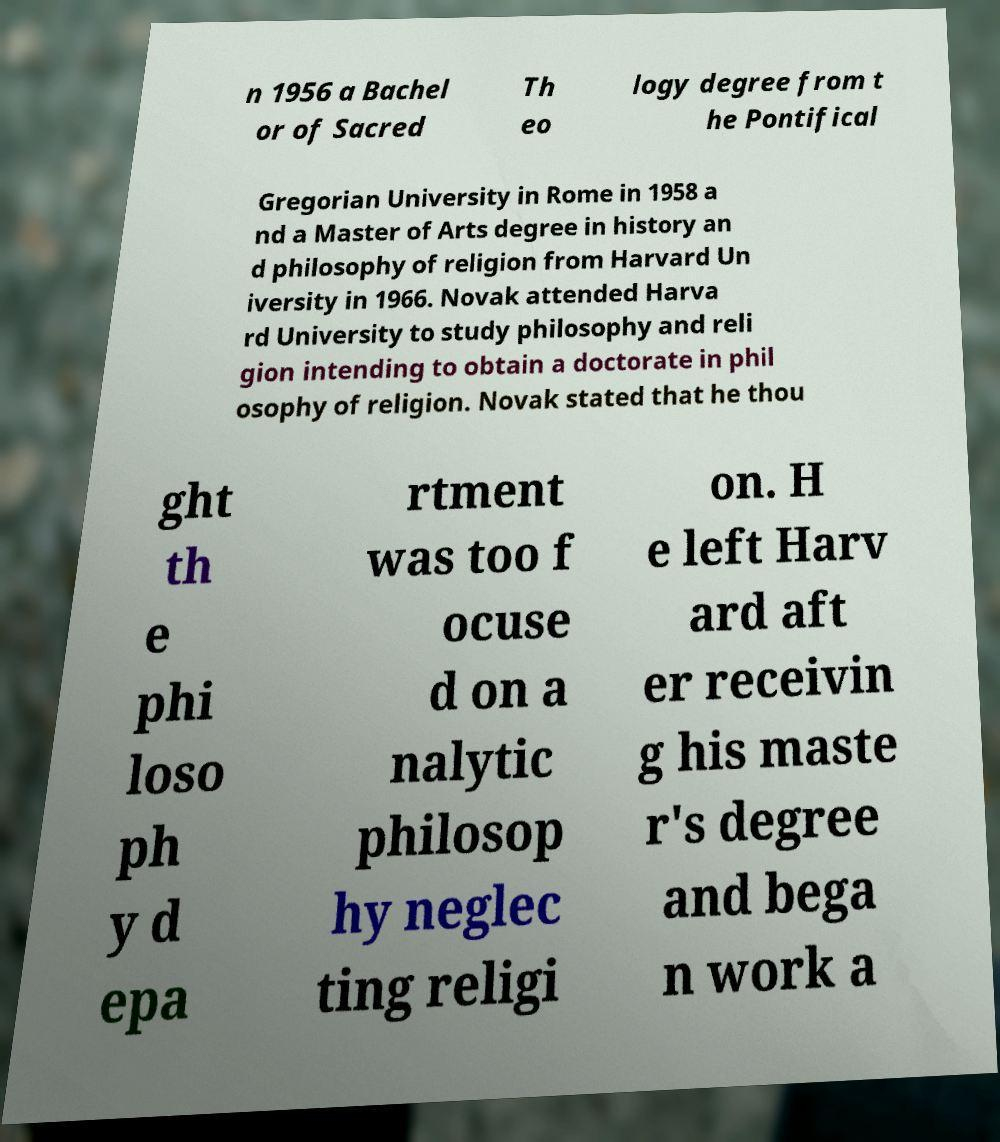Can you read and provide the text displayed in the image?This photo seems to have some interesting text. Can you extract and type it out for me? n 1956 a Bachel or of Sacred Th eo logy degree from t he Pontifical Gregorian University in Rome in 1958 a nd a Master of Arts degree in history an d philosophy of religion from Harvard Un iversity in 1966. Novak attended Harva rd University to study philosophy and reli gion intending to obtain a doctorate in phil osophy of religion. Novak stated that he thou ght th e phi loso ph y d epa rtment was too f ocuse d on a nalytic philosop hy neglec ting religi on. H e left Harv ard aft er receivin g his maste r's degree and bega n work a 